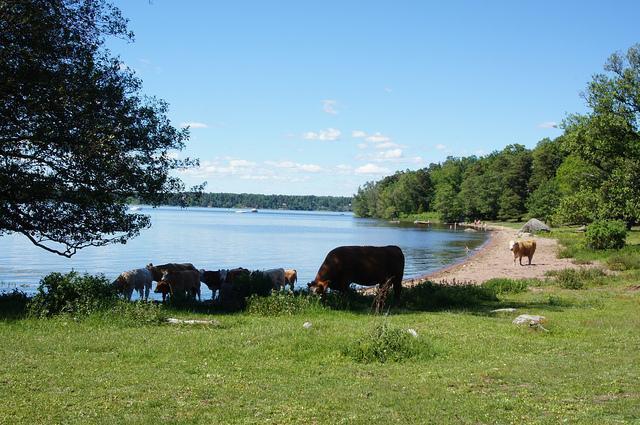How many animal species are shown NOT including the people on shore?
Select the correct answer and articulate reasoning with the following format: 'Answer: answer
Rationale: rationale.'
Options: One, nine, 11, five. Answer: one.
Rationale: One species is shown. 